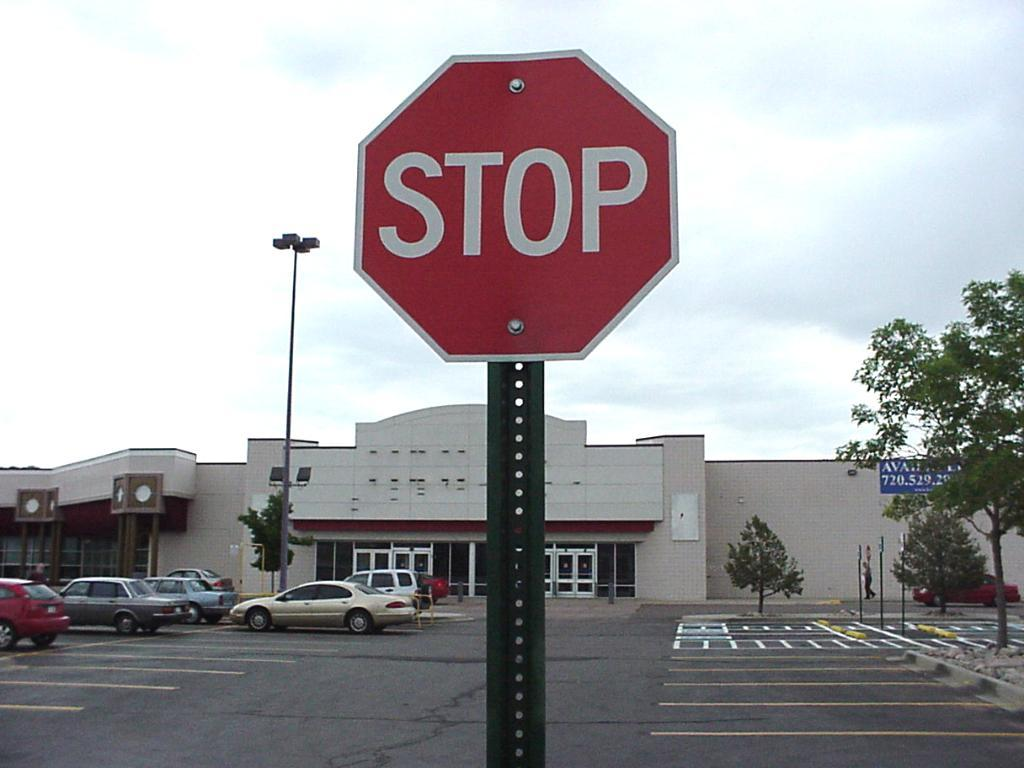<image>
Summarize the visual content of the image. A stop sign is positioned in a parking lot of a vacant store. 